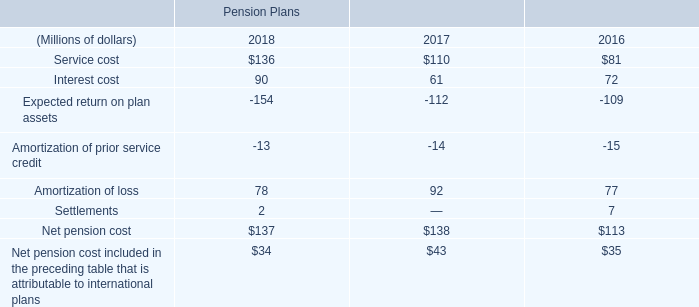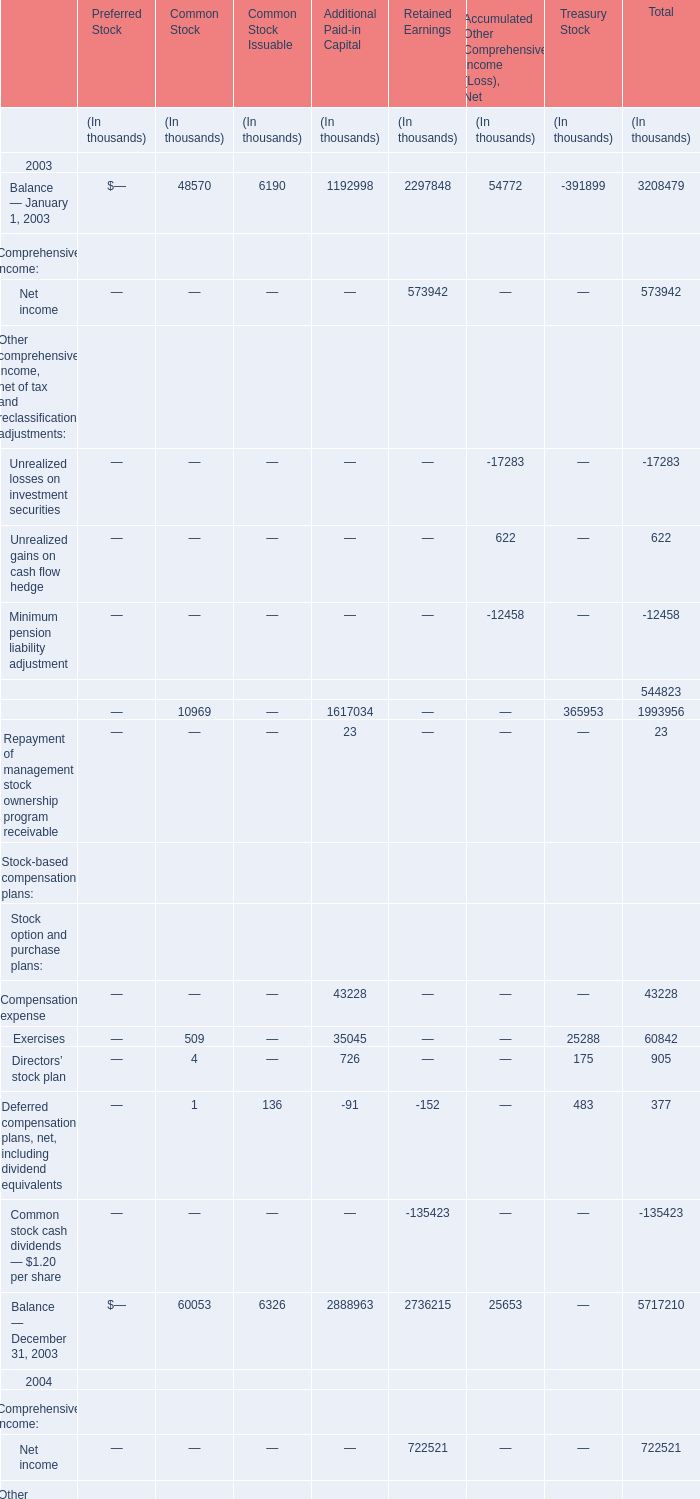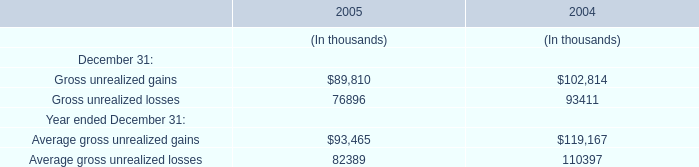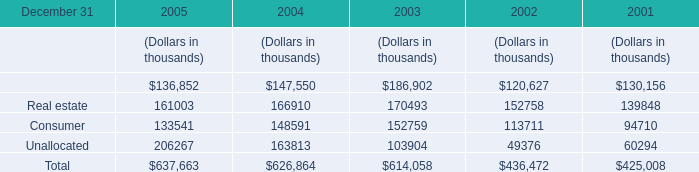What is the sum of the Balance on December 31 in 2005 for Common Stock? (in thousand) 
Answer: 60198. 